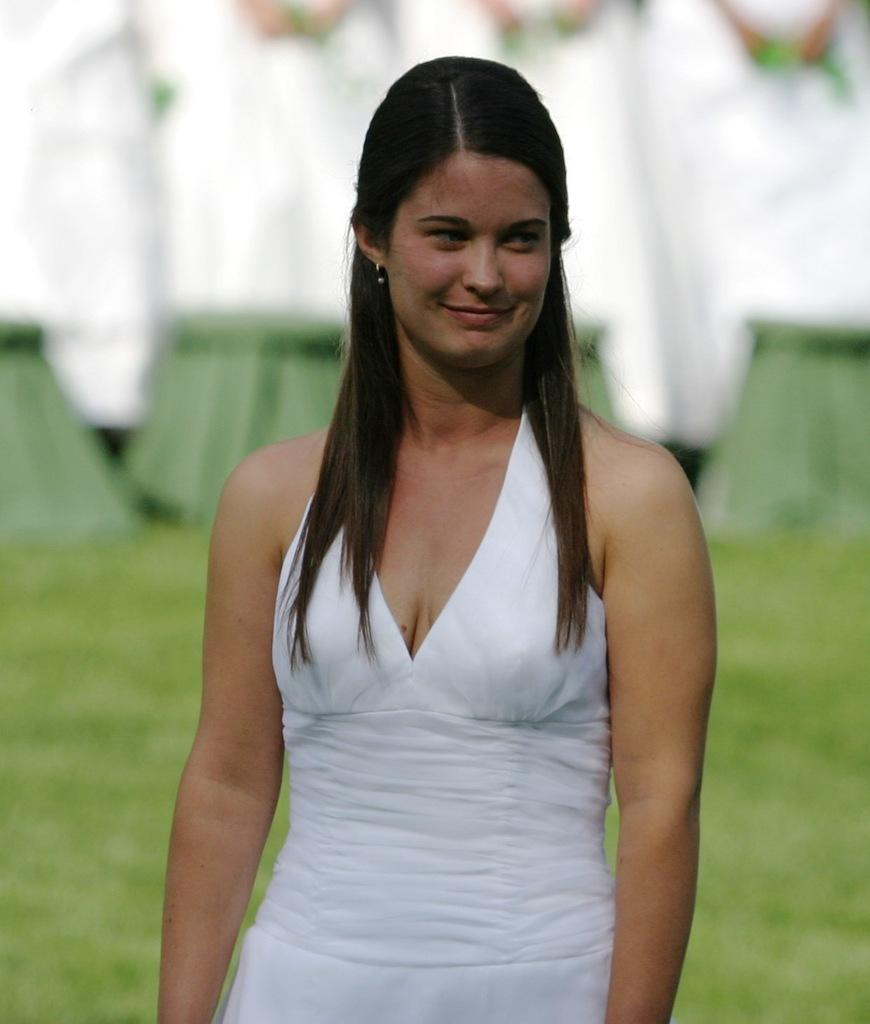Who is the main subject in the image? There is a woman in the image. What is the woman doing in the image? The woman is standing on the ground. What is the distance between the woman and the nearest tree in the image? There is no information about a tree or its distance from the woman in the image. 